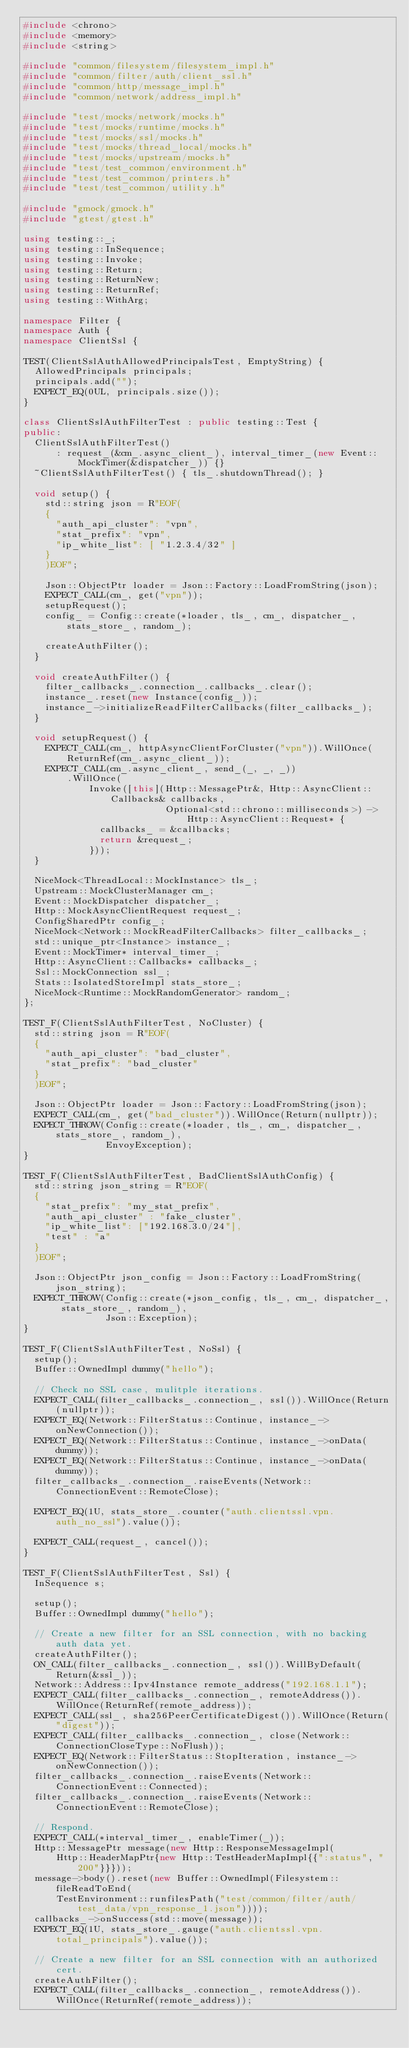<code> <loc_0><loc_0><loc_500><loc_500><_C++_>#include <chrono>
#include <memory>
#include <string>

#include "common/filesystem/filesystem_impl.h"
#include "common/filter/auth/client_ssl.h"
#include "common/http/message_impl.h"
#include "common/network/address_impl.h"

#include "test/mocks/network/mocks.h"
#include "test/mocks/runtime/mocks.h"
#include "test/mocks/ssl/mocks.h"
#include "test/mocks/thread_local/mocks.h"
#include "test/mocks/upstream/mocks.h"
#include "test/test_common/environment.h"
#include "test/test_common/printers.h"
#include "test/test_common/utility.h"

#include "gmock/gmock.h"
#include "gtest/gtest.h"

using testing::_;
using testing::InSequence;
using testing::Invoke;
using testing::Return;
using testing::ReturnNew;
using testing::ReturnRef;
using testing::WithArg;

namespace Filter {
namespace Auth {
namespace ClientSsl {

TEST(ClientSslAuthAllowedPrincipalsTest, EmptyString) {
  AllowedPrincipals principals;
  principals.add("");
  EXPECT_EQ(0UL, principals.size());
}

class ClientSslAuthFilterTest : public testing::Test {
public:
  ClientSslAuthFilterTest()
      : request_(&cm_.async_client_), interval_timer_(new Event::MockTimer(&dispatcher_)) {}
  ~ClientSslAuthFilterTest() { tls_.shutdownThread(); }

  void setup() {
    std::string json = R"EOF(
    {
      "auth_api_cluster": "vpn",
      "stat_prefix": "vpn",
      "ip_white_list": [ "1.2.3.4/32" ]
    }
    )EOF";

    Json::ObjectPtr loader = Json::Factory::LoadFromString(json);
    EXPECT_CALL(cm_, get("vpn"));
    setupRequest();
    config_ = Config::create(*loader, tls_, cm_, dispatcher_, stats_store_, random_);

    createAuthFilter();
  }

  void createAuthFilter() {
    filter_callbacks_.connection_.callbacks_.clear();
    instance_.reset(new Instance(config_));
    instance_->initializeReadFilterCallbacks(filter_callbacks_);
  }

  void setupRequest() {
    EXPECT_CALL(cm_, httpAsyncClientForCluster("vpn")).WillOnce(ReturnRef(cm_.async_client_));
    EXPECT_CALL(cm_.async_client_, send_(_, _, _))
        .WillOnce(
            Invoke([this](Http::MessagePtr&, Http::AsyncClient::Callbacks& callbacks,
                          Optional<std::chrono::milliseconds>) -> Http::AsyncClient::Request* {
              callbacks_ = &callbacks;
              return &request_;
            }));
  }

  NiceMock<ThreadLocal::MockInstance> tls_;
  Upstream::MockClusterManager cm_;
  Event::MockDispatcher dispatcher_;
  Http::MockAsyncClientRequest request_;
  ConfigSharedPtr config_;
  NiceMock<Network::MockReadFilterCallbacks> filter_callbacks_;
  std::unique_ptr<Instance> instance_;
  Event::MockTimer* interval_timer_;
  Http::AsyncClient::Callbacks* callbacks_;
  Ssl::MockConnection ssl_;
  Stats::IsolatedStoreImpl stats_store_;
  NiceMock<Runtime::MockRandomGenerator> random_;
};

TEST_F(ClientSslAuthFilterTest, NoCluster) {
  std::string json = R"EOF(
  {
    "auth_api_cluster": "bad_cluster",
    "stat_prefix": "bad_cluster"
  }
  )EOF";

  Json::ObjectPtr loader = Json::Factory::LoadFromString(json);
  EXPECT_CALL(cm_, get("bad_cluster")).WillOnce(Return(nullptr));
  EXPECT_THROW(Config::create(*loader, tls_, cm_, dispatcher_, stats_store_, random_),
               EnvoyException);
}

TEST_F(ClientSslAuthFilterTest, BadClientSslAuthConfig) {
  std::string json_string = R"EOF(
  {
    "stat_prefix": "my_stat_prefix",
    "auth_api_cluster" : "fake_cluster",
    "ip_white_list": ["192.168.3.0/24"],
    "test" : "a"
  }
  )EOF";

  Json::ObjectPtr json_config = Json::Factory::LoadFromString(json_string);
  EXPECT_THROW(Config::create(*json_config, tls_, cm_, dispatcher_, stats_store_, random_),
               Json::Exception);
}

TEST_F(ClientSslAuthFilterTest, NoSsl) {
  setup();
  Buffer::OwnedImpl dummy("hello");

  // Check no SSL case, mulitple iterations.
  EXPECT_CALL(filter_callbacks_.connection_, ssl()).WillOnce(Return(nullptr));
  EXPECT_EQ(Network::FilterStatus::Continue, instance_->onNewConnection());
  EXPECT_EQ(Network::FilterStatus::Continue, instance_->onData(dummy));
  EXPECT_EQ(Network::FilterStatus::Continue, instance_->onData(dummy));
  filter_callbacks_.connection_.raiseEvents(Network::ConnectionEvent::RemoteClose);

  EXPECT_EQ(1U, stats_store_.counter("auth.clientssl.vpn.auth_no_ssl").value());

  EXPECT_CALL(request_, cancel());
}

TEST_F(ClientSslAuthFilterTest, Ssl) {
  InSequence s;

  setup();
  Buffer::OwnedImpl dummy("hello");

  // Create a new filter for an SSL connection, with no backing auth data yet.
  createAuthFilter();
  ON_CALL(filter_callbacks_.connection_, ssl()).WillByDefault(Return(&ssl_));
  Network::Address::Ipv4Instance remote_address("192.168.1.1");
  EXPECT_CALL(filter_callbacks_.connection_, remoteAddress()).WillOnce(ReturnRef(remote_address));
  EXPECT_CALL(ssl_, sha256PeerCertificateDigest()).WillOnce(Return("digest"));
  EXPECT_CALL(filter_callbacks_.connection_, close(Network::ConnectionCloseType::NoFlush));
  EXPECT_EQ(Network::FilterStatus::StopIteration, instance_->onNewConnection());
  filter_callbacks_.connection_.raiseEvents(Network::ConnectionEvent::Connected);
  filter_callbacks_.connection_.raiseEvents(Network::ConnectionEvent::RemoteClose);

  // Respond.
  EXPECT_CALL(*interval_timer_, enableTimer(_));
  Http::MessagePtr message(new Http::ResponseMessageImpl(
      Http::HeaderMapPtr{new Http::TestHeaderMapImpl{{":status", "200"}}}));
  message->body().reset(new Buffer::OwnedImpl(Filesystem::fileReadToEnd(
      TestEnvironment::runfilesPath("test/common/filter/auth/test_data/vpn_response_1.json"))));
  callbacks_->onSuccess(std::move(message));
  EXPECT_EQ(1U, stats_store_.gauge("auth.clientssl.vpn.total_principals").value());

  // Create a new filter for an SSL connection with an authorized cert.
  createAuthFilter();
  EXPECT_CALL(filter_callbacks_.connection_, remoteAddress()).WillOnce(ReturnRef(remote_address));</code> 